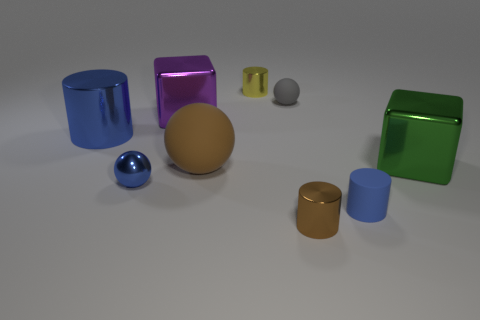Subtract all metallic balls. How many balls are left? 2 Subtract 1 blocks. How many blocks are left? 1 Subtract all purple cubes. How many cubes are left? 1 Add 8 big yellow matte things. How many big yellow matte things exist? 8 Subtract 0 red cubes. How many objects are left? 9 Subtract all blocks. How many objects are left? 7 Subtract all green cylinders. Subtract all yellow blocks. How many cylinders are left? 4 Subtract all gray blocks. How many brown cylinders are left? 1 Subtract all blue rubber cubes. Subtract all small yellow metallic objects. How many objects are left? 8 Add 8 yellow metal objects. How many yellow metal objects are left? 9 